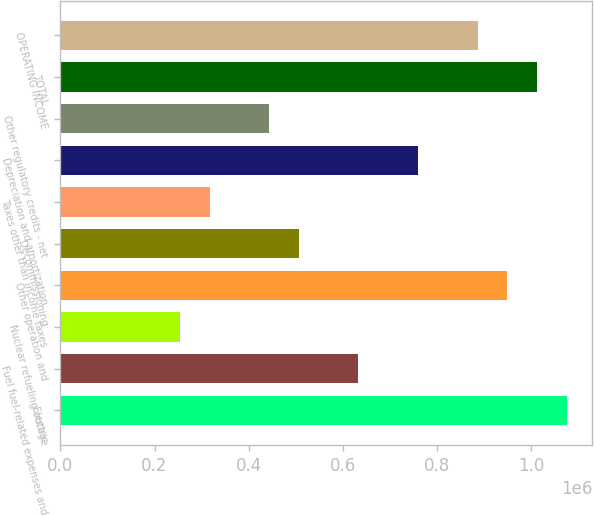Convert chart. <chart><loc_0><loc_0><loc_500><loc_500><bar_chart><fcel>Electric<fcel>Fuel fuel-related expenses and<fcel>Nuclear refueling outage<fcel>Other operation and<fcel>Decommissioning<fcel>Taxes other than income taxes<fcel>Depreciation and amortization<fcel>Other regulatory credits - net<fcel>TOTAL<fcel>OPERATING INCOME<nl><fcel>1.07651e+06<fcel>633458<fcel>253696<fcel>949926<fcel>506871<fcel>316990<fcel>760045<fcel>443577<fcel>1.01322e+06<fcel>886633<nl></chart> 